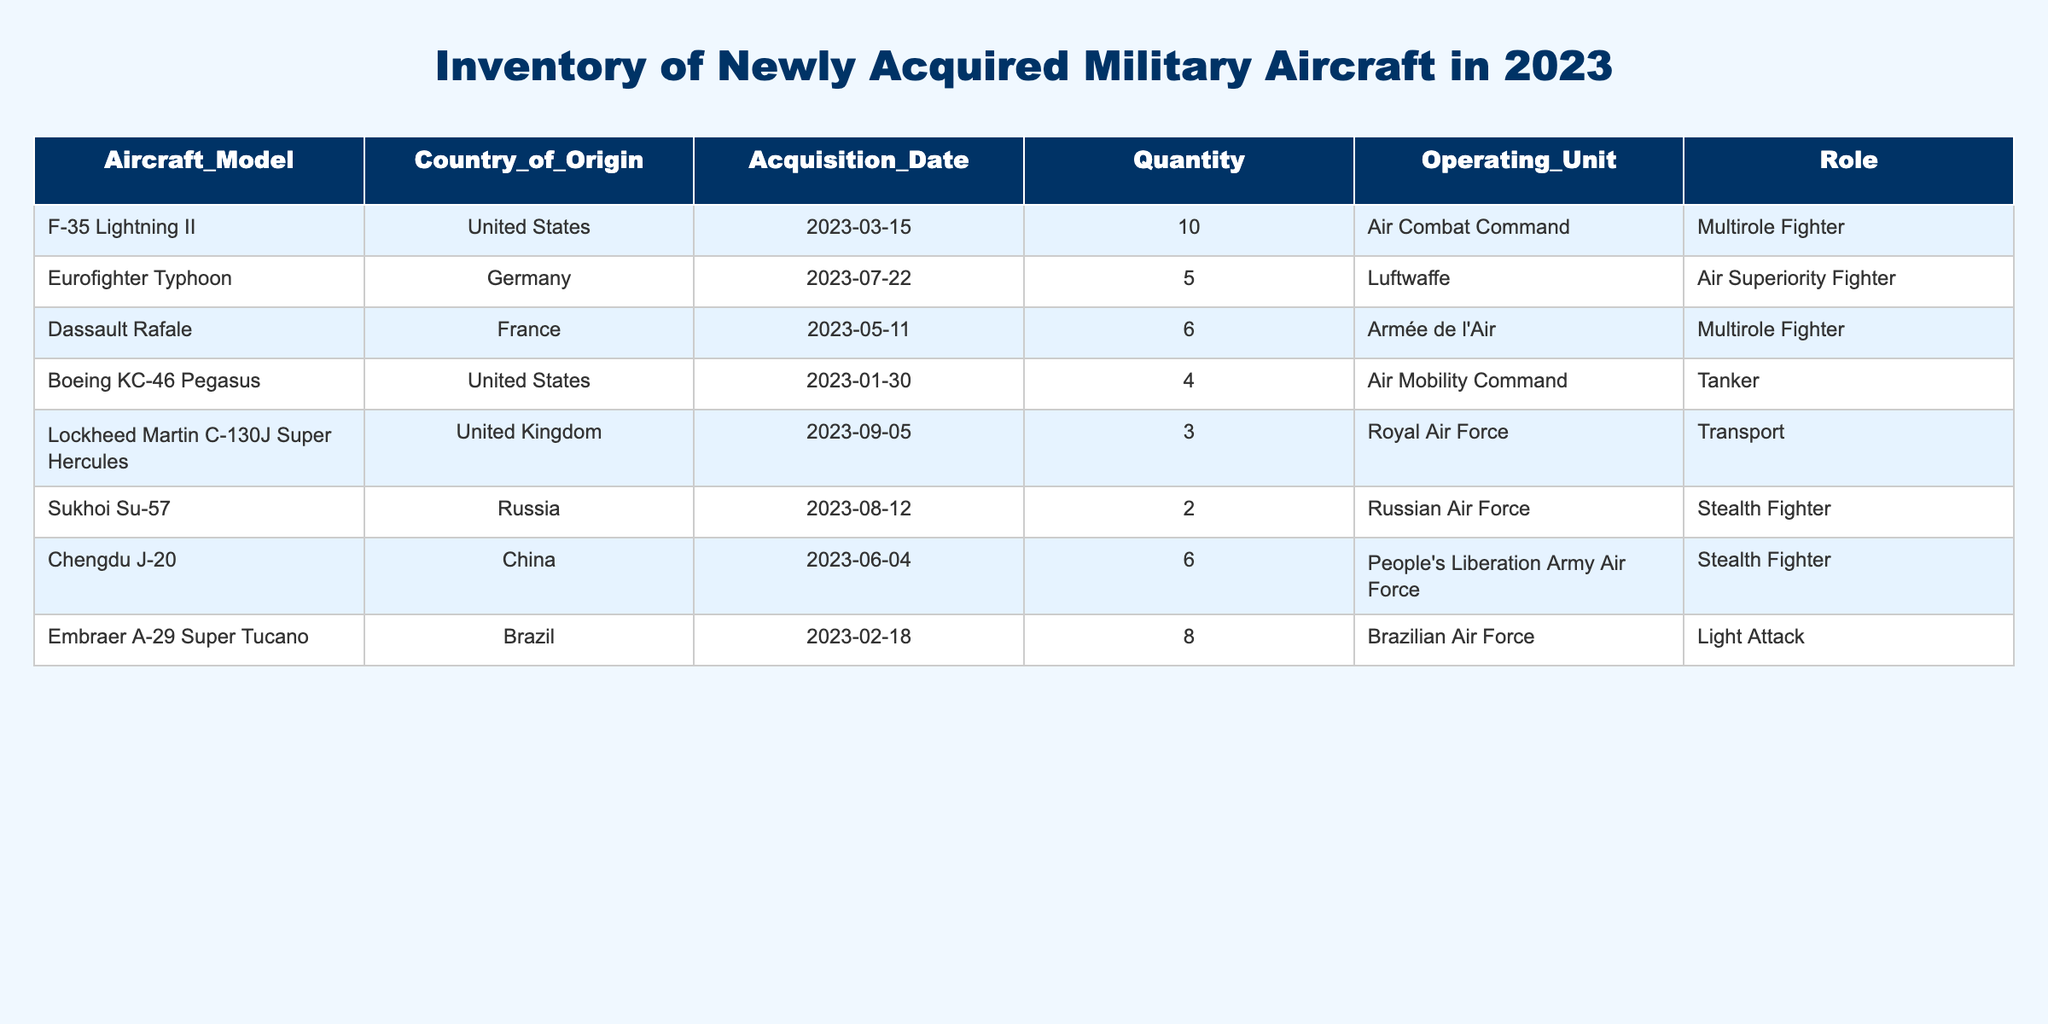What is the total quantity of F-35 Lightning II acquired? Looking at the table, I focus on the row for the F-35 Lightning II. The quantity listed in that row is 10, so I can directly state that 10 F-35 Lightning II aircraft were acquired.
Answer: 10 How many countries are represented in the inventory? By reviewing the 'Country of Origin' column in the table, I see the countries listed are the United States, Germany, France, the United Kingdom, Russia, China, and Brazil. Counting these distinct countries gives a total of 7.
Answer: 7 What is the combined quantity of multirole fighters acquired in 2023? First, I identify the rows for the multirole fighters, which include F-35 Lightning II and Dassault Rafale. Their respective quantities are 10 and 6. Adding them together, 10 + 6 equals 16, so the total is 16 for multirole fighters.
Answer: 16 Is there any aircraft acquired by the Russian Air Force? I check the 'Operating Unit' column for any mention of the Russian Air Force. I find one entry: the Sukhoi Su-57. Therefore, yes, there is an aircraft acquired by the Russian Air Force.
Answer: Yes What is the average quantity of aircraft acquired from Europe? I identify the European aircraft: Eurofighter Typhoon (5) from Germany, Dassault Rafale (6) from France, and Lockheed Martin C-130J Super Hercules (3) from the United Kingdom. The total quantity is 5 + 6 + 3 = 14. Since there are 3 European countries represented, I divide 14 by 3, obtaining an average of approximately 4.67.
Answer: 4.67 Which aircraft has the least quantity acquired? I review the 'Quantity' column to find the lowest number. The Sukhoi Su-57 has a quantity of 2, which is lower than all other aircraft, indicating it has the least quantity acquired.
Answer: Sukhoi Su-57 How many tanker aircraft were acquired, and what is their country of origin? I locate the aircraft categorized as tanker in the 'Role' column. The Boeing KC-46 Pegasus is the only tanker listed, and it has a quantity of 4 with the United States as its country of origin.
Answer: 4, United States How many stealth fighters did the People's Liberation Army Air Force acquire? Looking at the table, I see the Chengdu J-20 is listed under the People's Liberation Army Air Force and it indicates a quantity of 6. Therefore, the amount is 6.
Answer: 6 